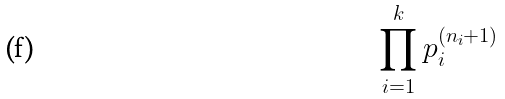Convert formula to latex. <formula><loc_0><loc_0><loc_500><loc_500>\prod _ { i = 1 } ^ { k } p _ { i } ^ { ( n _ { i } + 1 ) }</formula> 